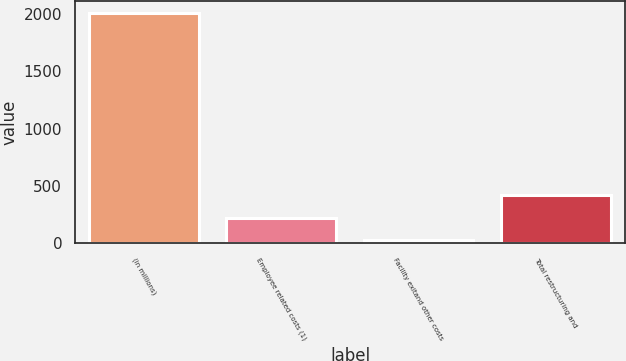Convert chart to OTSL. <chart><loc_0><loc_0><loc_500><loc_500><bar_chart><fcel>(in millions)<fcel>Employee related costs (1)<fcel>Facility exitand other costs<fcel>Total restructuring and<nl><fcel>2008<fcel>223.57<fcel>25.3<fcel>421.84<nl></chart> 